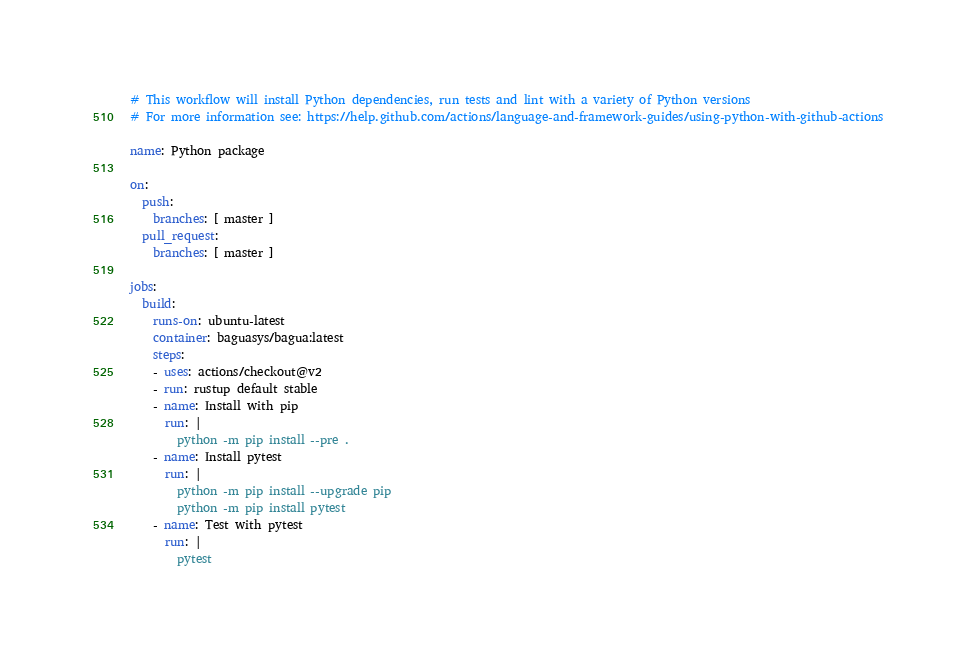Convert code to text. <code><loc_0><loc_0><loc_500><loc_500><_YAML_># This workflow will install Python dependencies, run tests and lint with a variety of Python versions
# For more information see: https://help.github.com/actions/language-and-framework-guides/using-python-with-github-actions

name: Python package

on:
  push:
    branches: [ master ]
  pull_request:
    branches: [ master ]

jobs:
  build:
    runs-on: ubuntu-latest
    container: baguasys/bagua:latest
    steps:
    - uses: actions/checkout@v2
    - run: rustup default stable
    - name: Install with pip
      run: |
        python -m pip install --pre .
    - name: Install pytest
      run: |
        python -m pip install --upgrade pip
        python -m pip install pytest
    - name: Test with pytest
      run: |
        pytest
</code> 